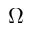<formula> <loc_0><loc_0><loc_500><loc_500>\Omega</formula> 